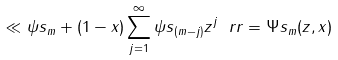<formula> <loc_0><loc_0><loc_500><loc_500>\ll \psi s _ { m } + ( 1 - x ) \sum _ { j = 1 } ^ { \infty } \psi s _ { ( m - j ) } z ^ { j } \ r r = \Psi s _ { m } ( z , x )</formula> 